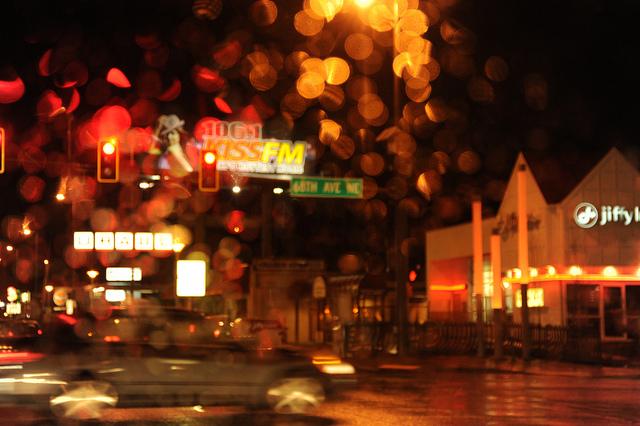What word is written in white on the building on the right?
Give a very brief answer. Jiffy. Is that a national radio station?
Write a very short answer. Yes. Are there any people in the street?
Answer briefly. No. 